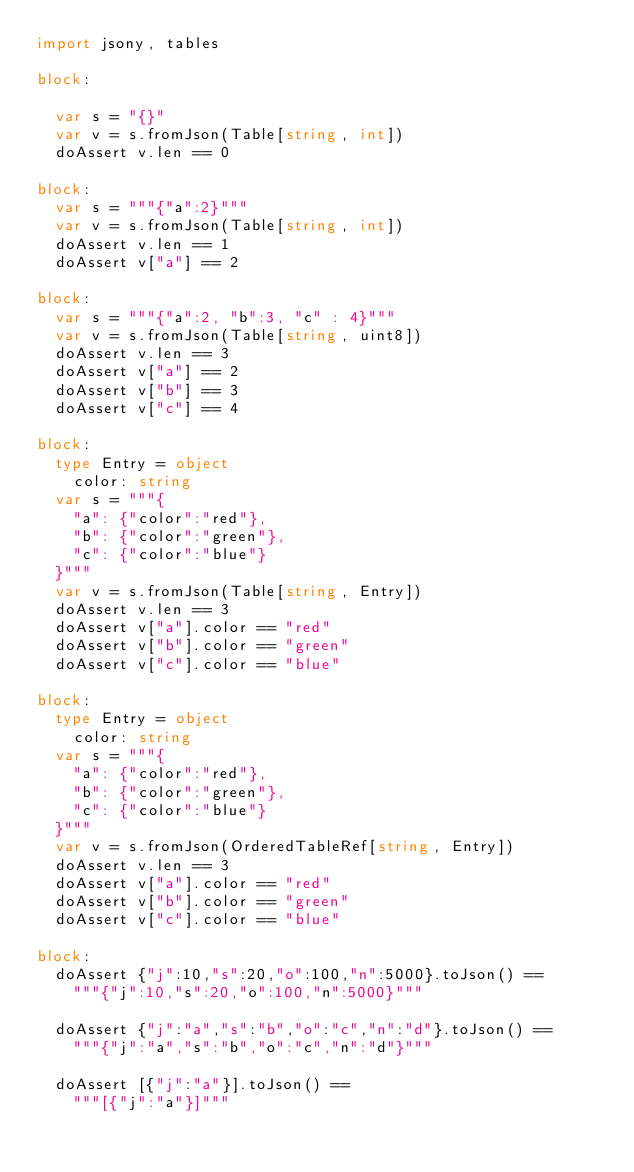<code> <loc_0><loc_0><loc_500><loc_500><_Nim_>import jsony, tables

block:

  var s = "{}"
  var v = s.fromJson(Table[string, int])
  doAssert v.len == 0

block:
  var s = """{"a":2}"""
  var v = s.fromJson(Table[string, int])
  doAssert v.len == 1
  doAssert v["a"] == 2

block:
  var s = """{"a":2, "b":3, "c" : 4}"""
  var v = s.fromJson(Table[string, uint8])
  doAssert v.len == 3
  doAssert v["a"] == 2
  doAssert v["b"] == 3
  doAssert v["c"] == 4

block:
  type Entry = object
    color: string
  var s = """{
    "a": {"color":"red"},
    "b": {"color":"green"},
    "c": {"color":"blue"}
  }"""
  var v = s.fromJson(Table[string, Entry])
  doAssert v.len == 3
  doAssert v["a"].color == "red"
  doAssert v["b"].color == "green"
  doAssert v["c"].color == "blue"

block:
  type Entry = object
    color: string
  var s = """{
    "a": {"color":"red"},
    "b": {"color":"green"},
    "c": {"color":"blue"}
  }"""
  var v = s.fromJson(OrderedTableRef[string, Entry])
  doAssert v.len == 3
  doAssert v["a"].color == "red"
  doAssert v["b"].color == "green"
  doAssert v["c"].color == "blue"

block:
  doAssert {"j":10,"s":20,"o":100,"n":5000}.toJson() ==
    """{"j":10,"s":20,"o":100,"n":5000}"""

  doAssert {"j":"a","s":"b","o":"c","n":"d"}.toJson() ==
    """{"j":"a","s":"b","o":"c","n":"d"}"""

  doAssert [{"j":"a"}].toJson() ==
    """[{"j":"a"}]"""
</code> 